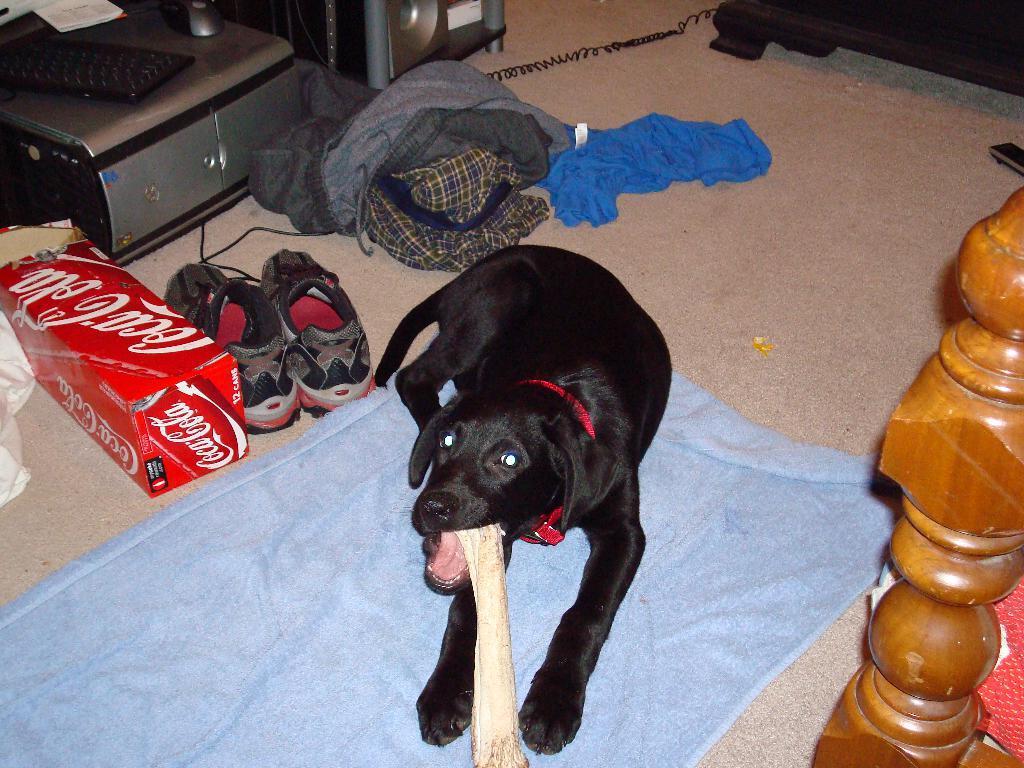In one or two sentences, can you explain what this image depicts? In the center of the picture there is a black color dog. On the left there are shoes, clothing, box, CPU, keyboard, speaker and other objects. On the right there is a cot. 